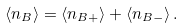Convert formula to latex. <formula><loc_0><loc_0><loc_500><loc_500>\langle n _ { B } \rangle = \langle n _ { B + } \rangle + \langle n _ { B - } \rangle \, .</formula> 